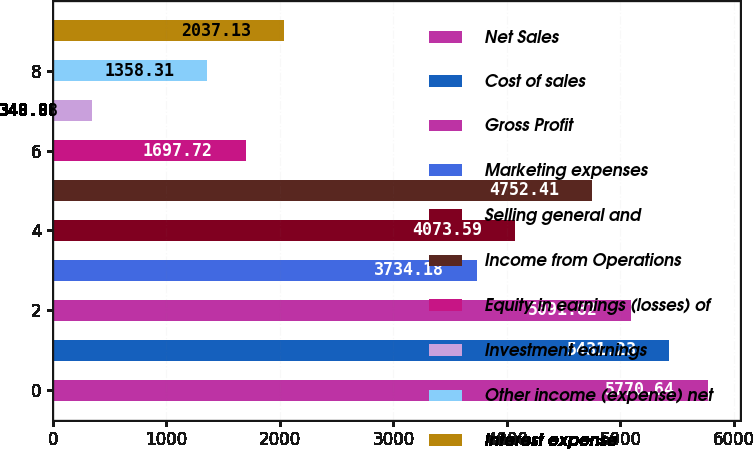Convert chart to OTSL. <chart><loc_0><loc_0><loc_500><loc_500><bar_chart><fcel>Net Sales<fcel>Cost of sales<fcel>Gross Profit<fcel>Marketing expenses<fcel>Selling general and<fcel>Income from Operations<fcel>Equity in earnings (losses) of<fcel>Investment earnings<fcel>Other income (expense) net<fcel>Interest expense<nl><fcel>5770.64<fcel>5431.23<fcel>5091.82<fcel>3734.18<fcel>4073.59<fcel>4752.41<fcel>1697.72<fcel>340.08<fcel>1358.31<fcel>2037.13<nl></chart> 